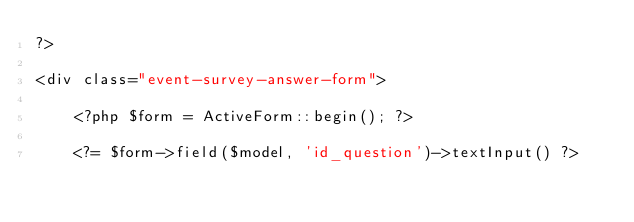<code> <loc_0><loc_0><loc_500><loc_500><_PHP_>?>

<div class="event-survey-answer-form">

    <?php $form = ActiveForm::begin(); ?>

    <?= $form->field($model, 'id_question')->textInput() ?>
</code> 